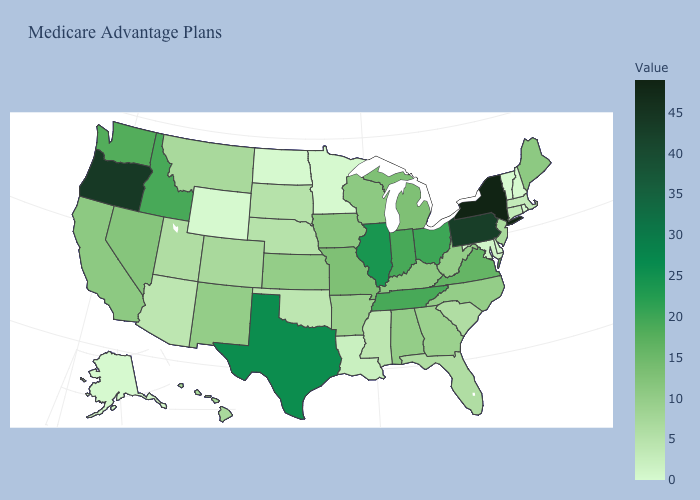Among the states that border Nevada , which have the lowest value?
Keep it brief. Arizona. Among the states that border Vermont , does Massachusetts have the highest value?
Answer briefly. No. Which states hav the highest value in the Northeast?
Write a very short answer. New York. 